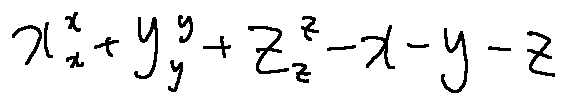Convert formula to latex. <formula><loc_0><loc_0><loc_500><loc_500>x _ { x } ^ { x } + y _ { y } ^ { y } + z _ { z } ^ { z } - x - y - z</formula> 